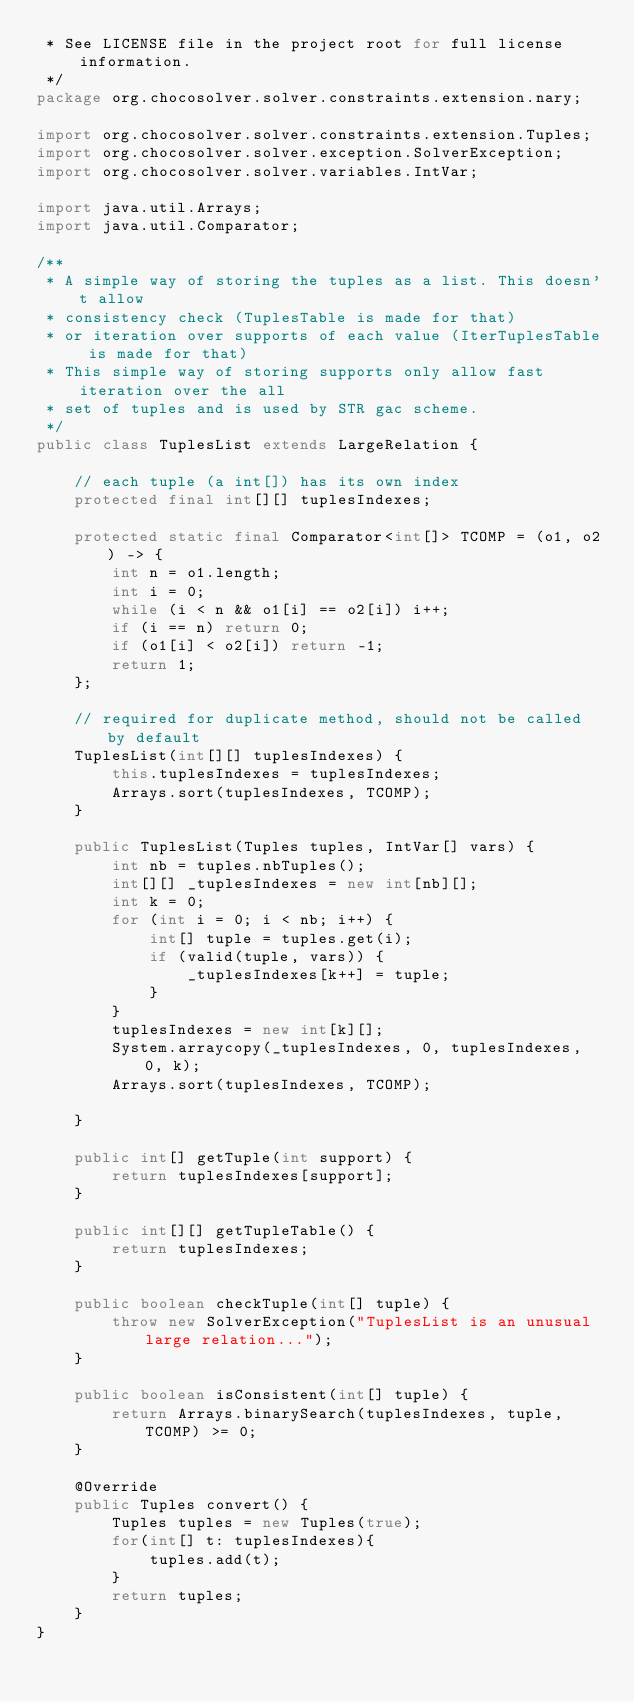Convert code to text. <code><loc_0><loc_0><loc_500><loc_500><_Java_> * See LICENSE file in the project root for full license information.
 */
package org.chocosolver.solver.constraints.extension.nary;

import org.chocosolver.solver.constraints.extension.Tuples;
import org.chocosolver.solver.exception.SolverException;
import org.chocosolver.solver.variables.IntVar;

import java.util.Arrays;
import java.util.Comparator;

/**
 * A simple way of storing the tuples as a list. This doesn't allow
 * consistency check (TuplesTable is made for that)
 * or iteration over supports of each value (IterTuplesTable is made for that)
 * This simple way of storing supports only allow fast iteration over the all
 * set of tuples and is used by STR gac scheme.
 */
public class TuplesList extends LargeRelation {

    // each tuple (a int[]) has its own index
    protected final int[][] tuplesIndexes;

    protected static final Comparator<int[]> TCOMP = (o1, o2) -> {
        int n = o1.length;
        int i = 0;
        while (i < n && o1[i] == o2[i]) i++;
        if (i == n) return 0;
        if (o1[i] < o2[i]) return -1;
        return 1;
    };

    // required for duplicate method, should not be called by default
    TuplesList(int[][] tuplesIndexes) {
        this.tuplesIndexes = tuplesIndexes;
        Arrays.sort(tuplesIndexes, TCOMP);
    }

    public TuplesList(Tuples tuples, IntVar[] vars) {
        int nb = tuples.nbTuples();
        int[][] _tuplesIndexes = new int[nb][];
        int k = 0;
        for (int i = 0; i < nb; i++) {
            int[] tuple = tuples.get(i);
            if (valid(tuple, vars)) {
                _tuplesIndexes[k++] = tuple;
            }
        }
        tuplesIndexes = new int[k][];
        System.arraycopy(_tuplesIndexes, 0, tuplesIndexes, 0, k);
        Arrays.sort(tuplesIndexes, TCOMP);

    }

    public int[] getTuple(int support) {
        return tuplesIndexes[support];
    }

    public int[][] getTupleTable() {
        return tuplesIndexes;
    }

    public boolean checkTuple(int[] tuple) {
        throw new SolverException("TuplesList is an unusual large relation...");
    }

    public boolean isConsistent(int[] tuple) {
        return Arrays.binarySearch(tuplesIndexes, tuple, TCOMP) >= 0;
    }

    @Override
    public Tuples convert() {
        Tuples tuples = new Tuples(true);
        for(int[] t: tuplesIndexes){
            tuples.add(t);
        }
        return tuples;
    }
}
</code> 